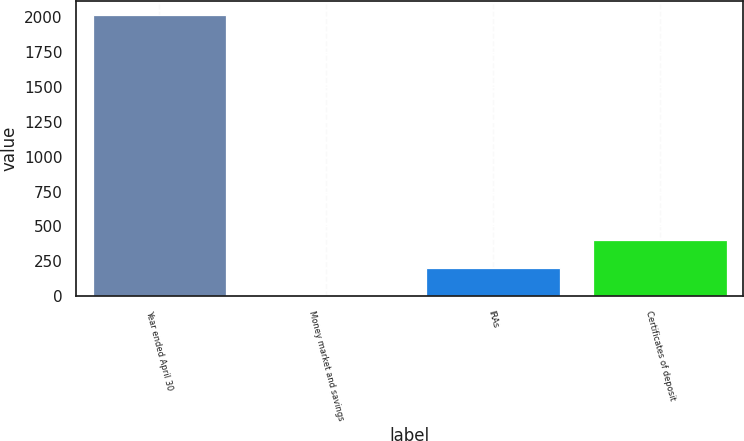<chart> <loc_0><loc_0><loc_500><loc_500><bar_chart><fcel>Year ended April 30<fcel>Money market and savings<fcel>IRAs<fcel>Certificates of deposit<nl><fcel>2013<fcel>0.59<fcel>201.83<fcel>403.07<nl></chart> 